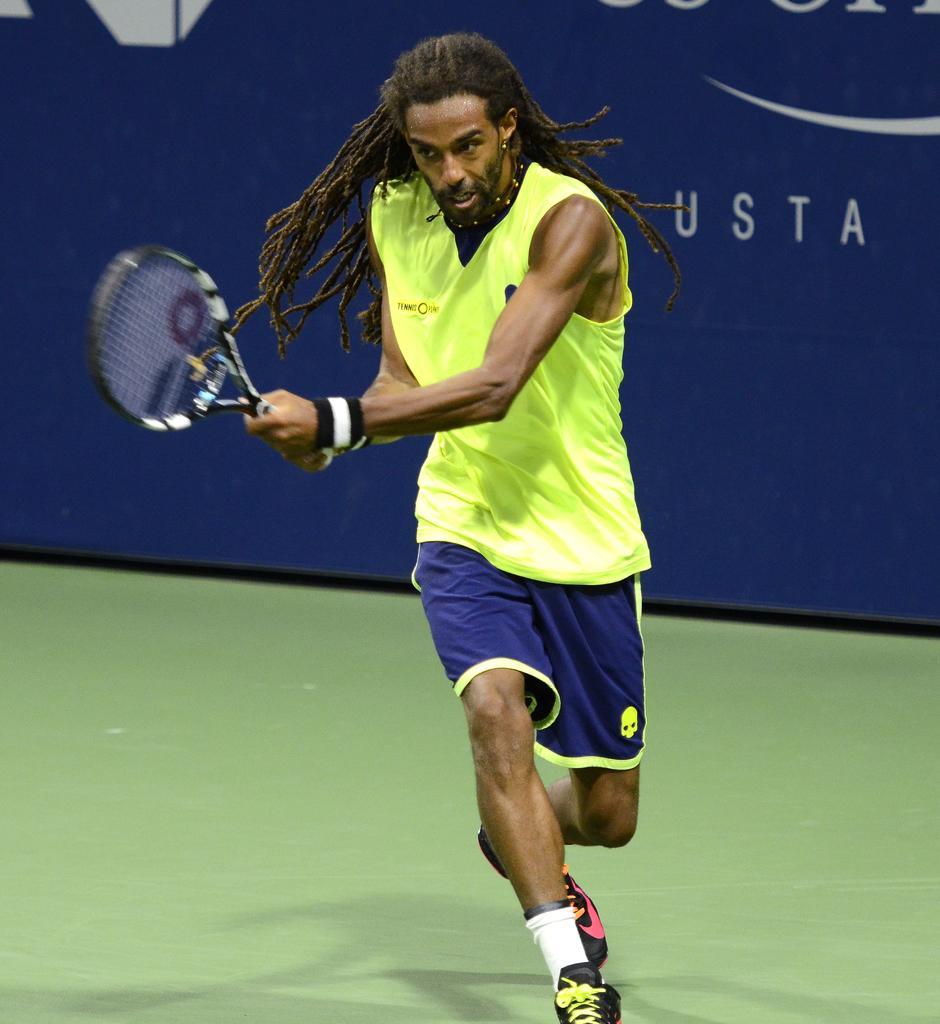Please provide a concise description of this image. In this image, we can see a person in front of the banner. This person is wearing clothes and holding a tennis racket with his hands. 